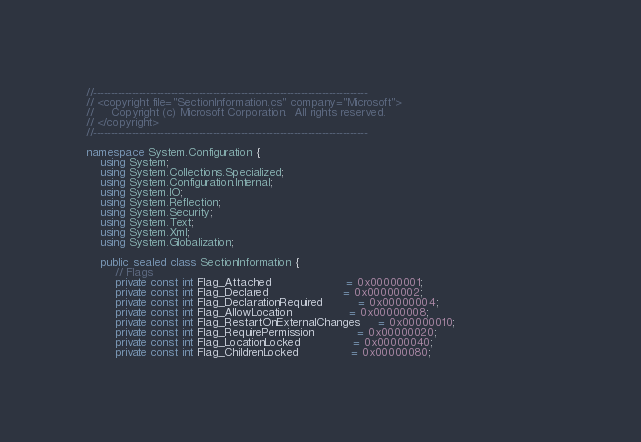Convert code to text. <code><loc_0><loc_0><loc_500><loc_500><_C#_>//------------------------------------------------------------------------------
// <copyright file="SectionInformation.cs" company="Microsoft">
//     Copyright (c) Microsoft Corporation.  All rights reserved.
// </copyright>
//------------------------------------------------------------------------------

namespace System.Configuration {
    using System;
    using System.Collections.Specialized;
    using System.Configuration.Internal;
    using System.IO;
    using System.Reflection;
    using System.Security;
    using System.Text;
    using System.Xml;
    using System.Globalization;

    public sealed class SectionInformation {
        // Flags
        private const int Flag_Attached                     = 0x00000001;
        private const int Flag_Declared                     = 0x00000002;
        private const int Flag_DeclarationRequired          = 0x00000004;
        private const int Flag_AllowLocation                = 0x00000008;
        private const int Flag_RestartOnExternalChanges     = 0x00000010;
        private const int Flag_RequirePermission            = 0x00000020;                                 
        private const int Flag_LocationLocked               = 0x00000040;
        private const int Flag_ChildrenLocked               = 0x00000080;</code> 